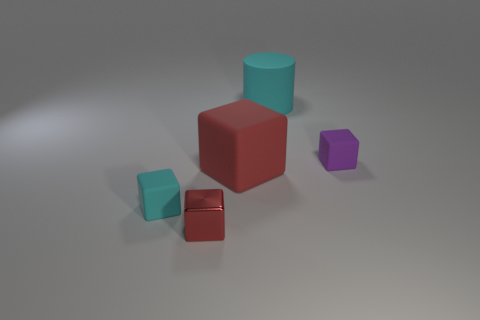Is the color of the big rubber cylinder the same as the metal object?
Make the answer very short. No. Is there a small gray rubber cylinder?
Offer a very short reply. No. Are there fewer small purple matte objects than green rubber things?
Provide a short and direct response. No. How many small cyan balls are made of the same material as the tiny purple object?
Ensure brevity in your answer.  0. What is the color of the other big cube that is made of the same material as the purple block?
Offer a very short reply. Red. What is the shape of the tiny red object?
Provide a succinct answer. Cube. What number of rubber blocks are the same color as the rubber cylinder?
Offer a terse response. 1. There is a purple matte object that is the same size as the cyan block; what is its shape?
Keep it short and to the point. Cube. Are there any red shiny objects that have the same size as the shiny cube?
Give a very brief answer. No. There is a red block that is the same size as the cyan matte block; what is its material?
Your answer should be compact. Metal. 